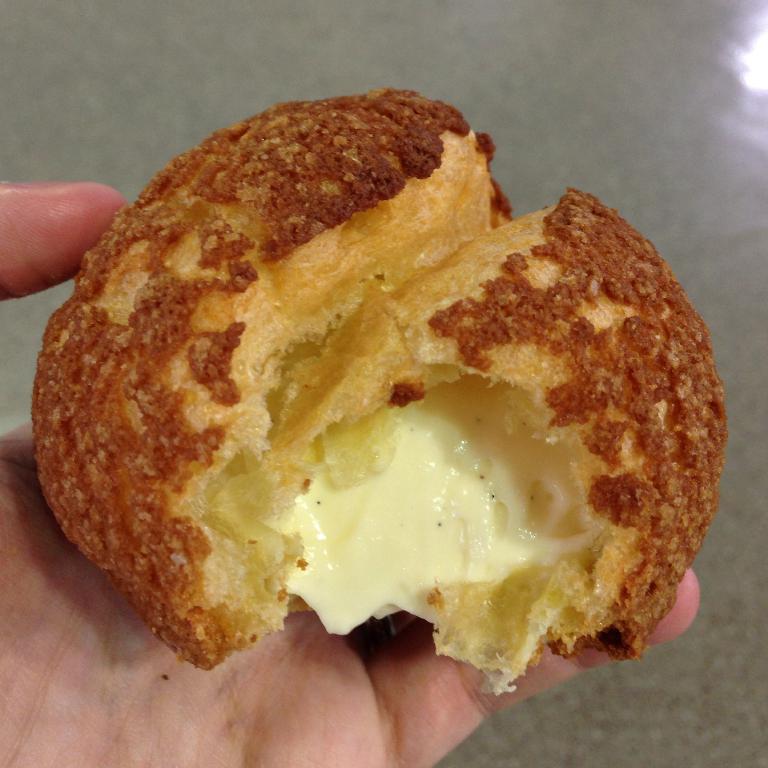Can you describe this image briefly? In this image, we can see a human hand is holding some food item. Here we can see a cream. Background there is a floor. 